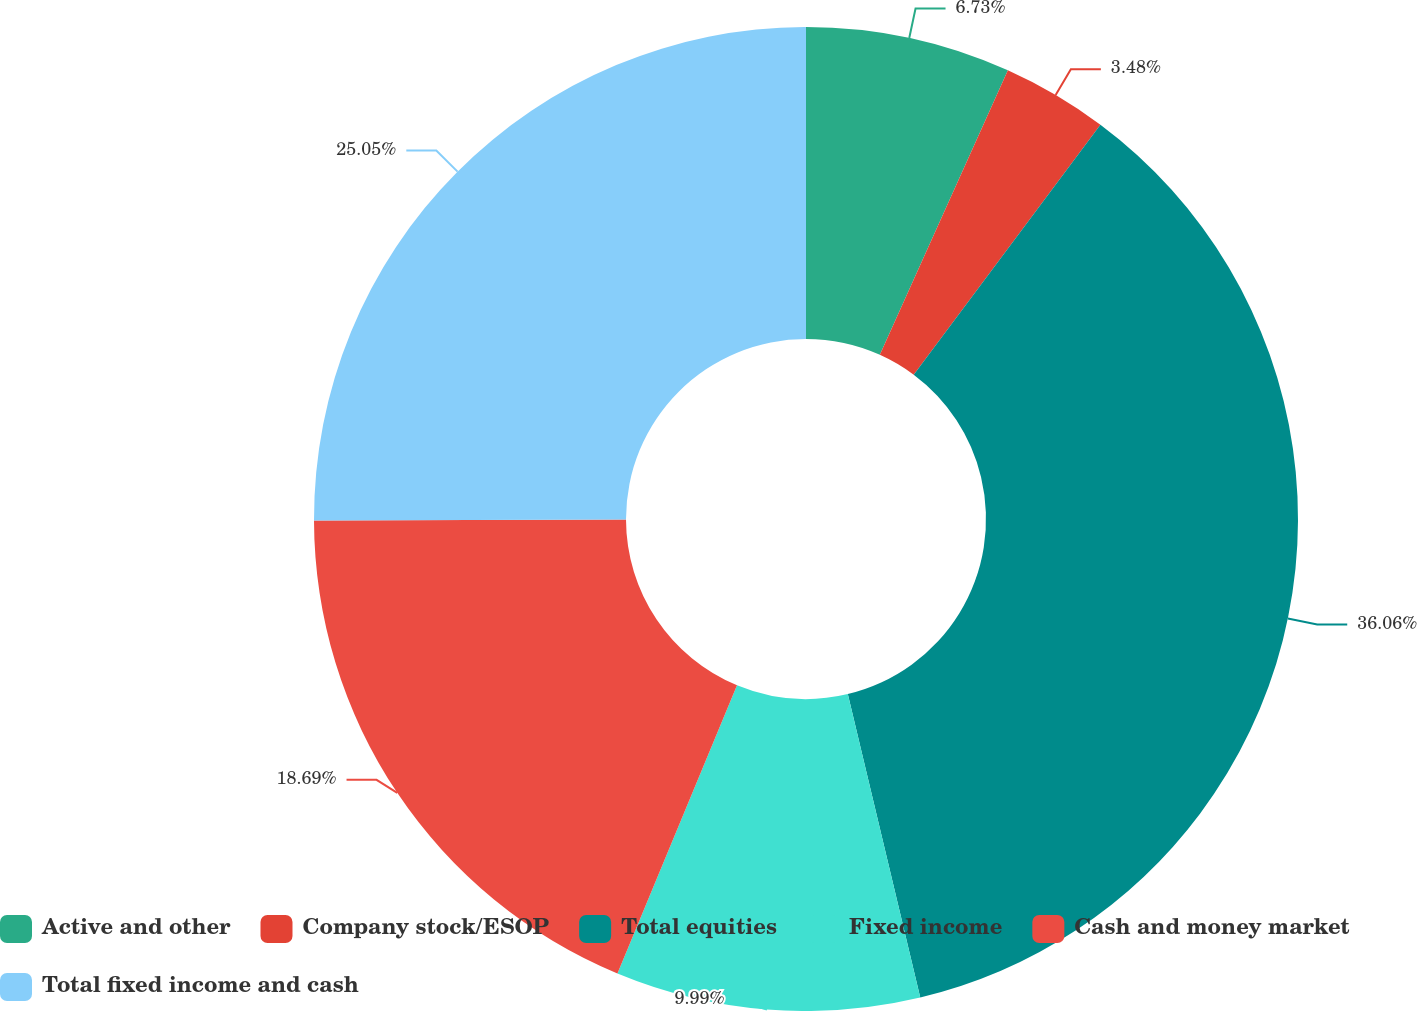Convert chart. <chart><loc_0><loc_0><loc_500><loc_500><pie_chart><fcel>Active and other<fcel>Company stock/ESOP<fcel>Total equities<fcel>Fixed income<fcel>Cash and money market<fcel>Total fixed income and cash<nl><fcel>6.73%<fcel>3.48%<fcel>36.06%<fcel>9.99%<fcel>18.69%<fcel>25.05%<nl></chart> 